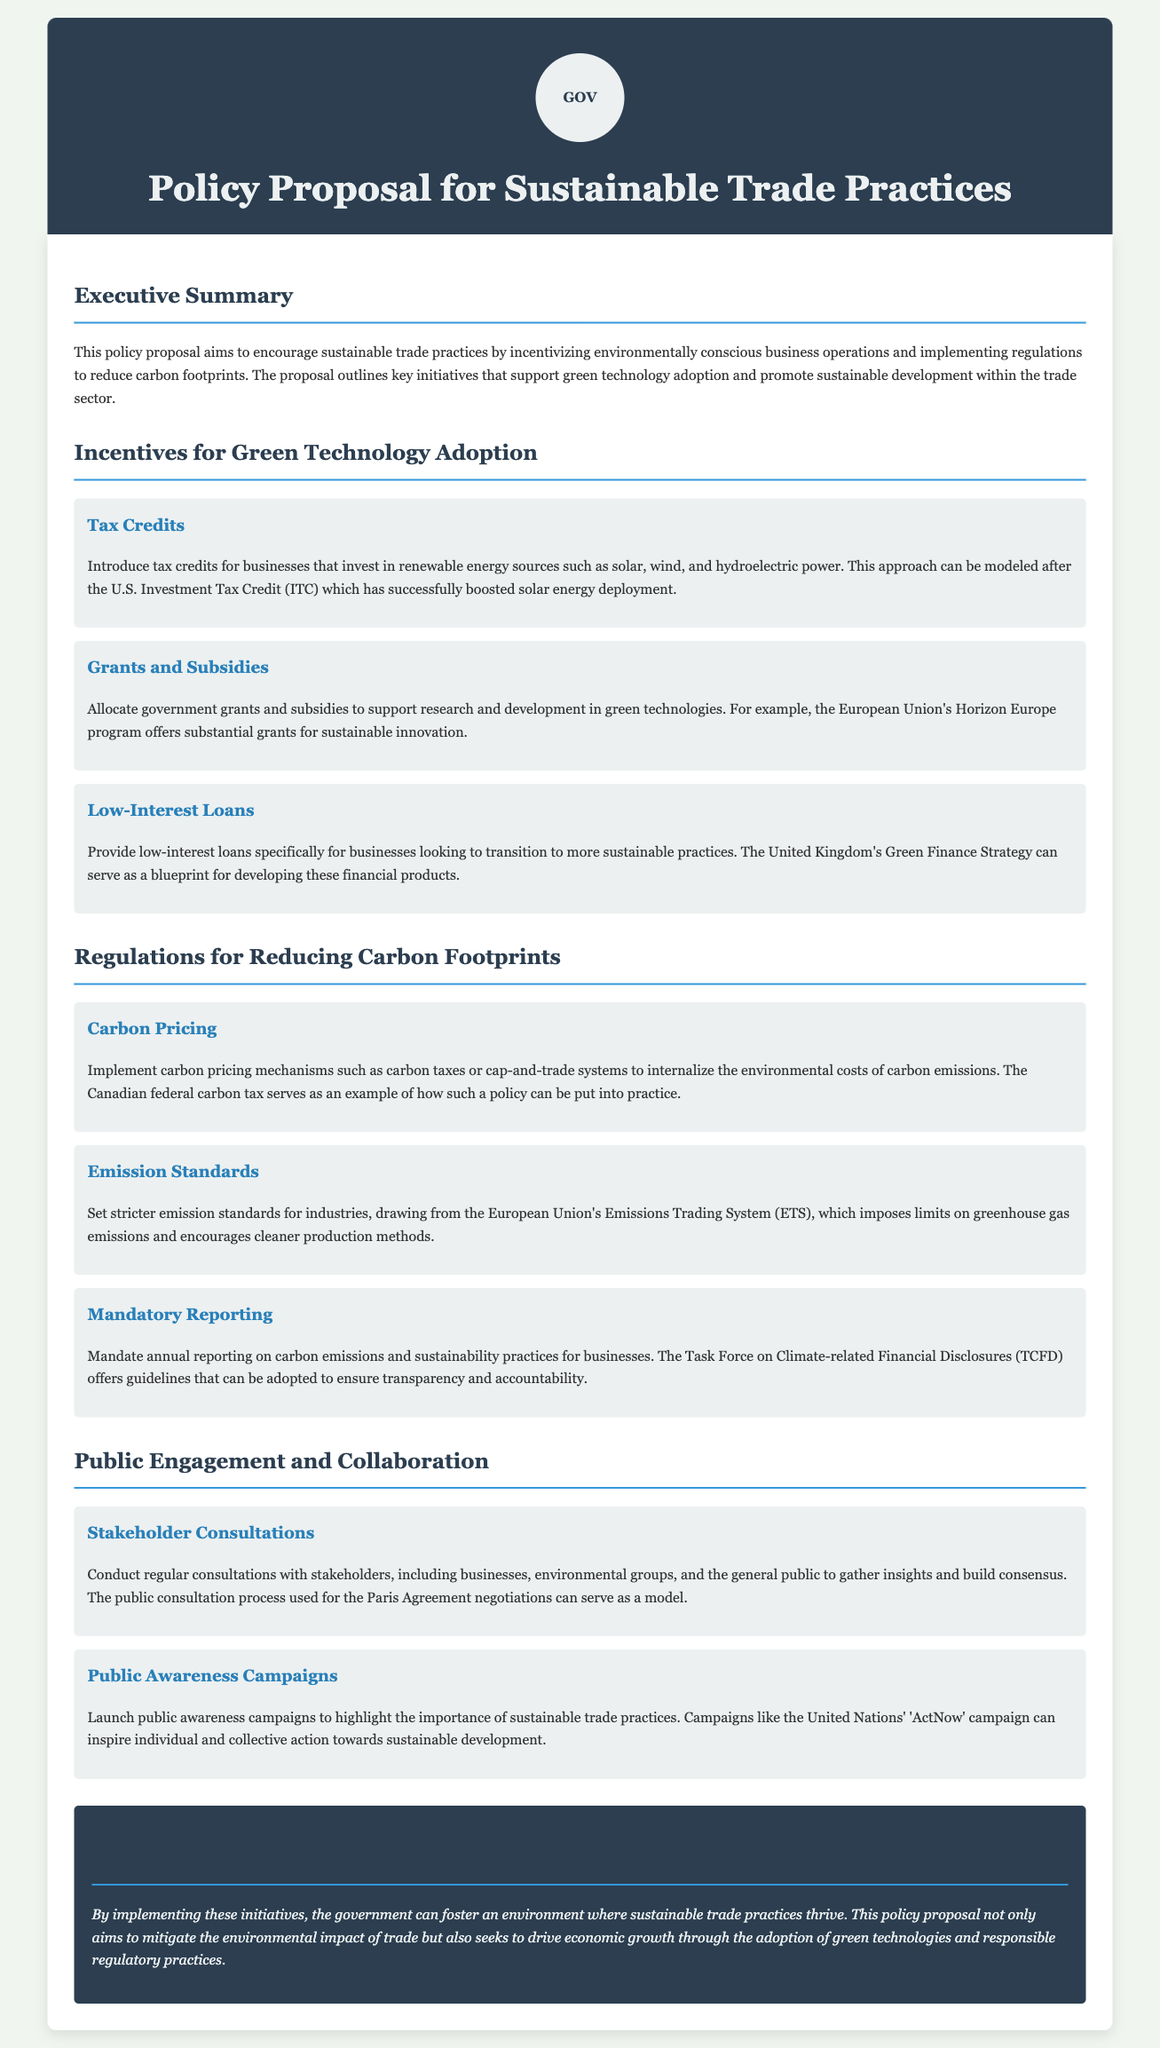What is the main aim of the policy proposal? The executive summary states that the main aim is to encourage sustainable trade practices.
Answer: Encourage sustainable trade practices What type of incentives are proposed for green technology adoption? The document outlines three types of incentives: tax credits, grants and subsidies, and low-interest loans.
Answer: Tax credits, grants and subsidies, low-interest loans Which country’s carbon tax is referenced as an example? The proposal mentions the Canadian federal carbon tax as an example of carbon pricing mechanisms.
Answer: Canadian federal carbon tax What does the proposal suggest for public engagement? It outlines two initiatives for public engagement: stakeholder consultations and public awareness campaigns.
Answer: Stakeholder consultations, public awareness campaigns What is one of the regulations proposed for reducing carbon footprints? The document suggests implementing carbon pricing mechanisms, such as carbon taxes or cap-and-trade systems.
Answer: Carbon pricing mechanisms What should businesses report annually according to the proposal? The document mandates annual reporting on carbon emissions and sustainability practices for businesses.
Answer: Carbon emissions and sustainability practices What initiative is suggested to support research in green technologies? The document suggests allocating government grants and subsidies to support research and development in green technologies.
Answer: Government grants and subsidies What is the title of the policy proposal? The title is explicitly stated in the header of the document.
Answer: Policy Proposal for Sustainable Trade Practices 